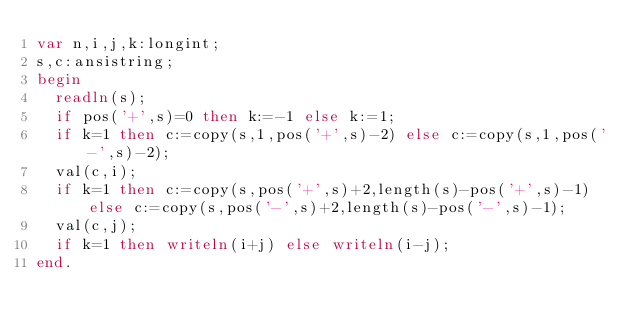Convert code to text. <code><loc_0><loc_0><loc_500><loc_500><_Pascal_>var n,i,j,k:longint;
s,c:ansistring;
begin
  readln(s);
  if pos('+',s)=0 then k:=-1 else k:=1;
  if k=1 then c:=copy(s,1,pos('+',s)-2) else c:=copy(s,1,pos('-',s)-2);
  val(c,i);
  if k=1 then c:=copy(s,pos('+',s)+2,length(s)-pos('+',s)-1) else c:=copy(s,pos('-',s)+2,length(s)-pos('-',s)-1);
  val(c,j);
  if k=1 then writeln(i+j) else writeln(i-j); 
end.
</code> 